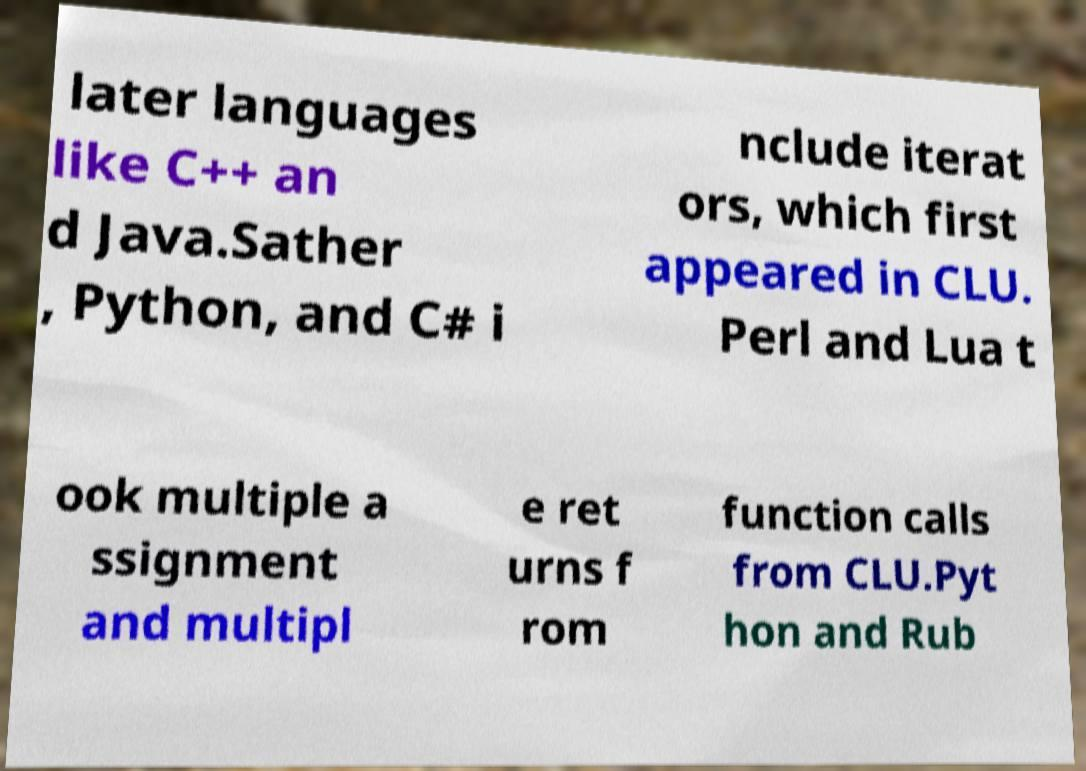There's text embedded in this image that I need extracted. Can you transcribe it verbatim? later languages like C++ an d Java.Sather , Python, and C# i nclude iterat ors, which first appeared in CLU. Perl and Lua t ook multiple a ssignment and multipl e ret urns f rom function calls from CLU.Pyt hon and Rub 